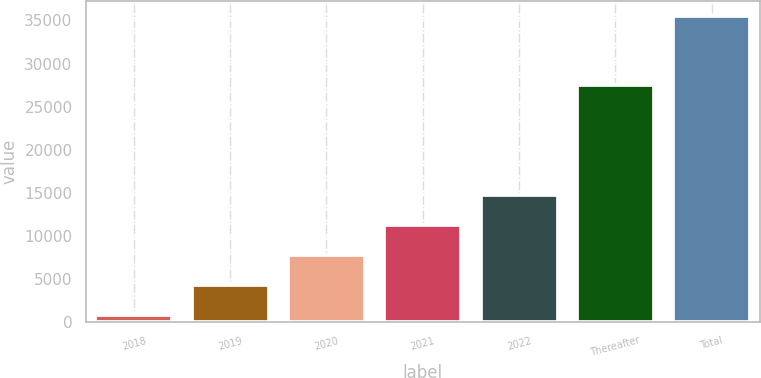Convert chart to OTSL. <chart><loc_0><loc_0><loc_500><loc_500><bar_chart><fcel>2018<fcel>2019<fcel>2020<fcel>2021<fcel>2022<fcel>Thereafter<fcel>Total<nl><fcel>888<fcel>4349.2<fcel>7810.4<fcel>11271.6<fcel>14732.8<fcel>27512<fcel>35500<nl></chart> 